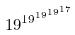Convert formula to latex. <formula><loc_0><loc_0><loc_500><loc_500>1 9 ^ { 1 9 ^ { 1 9 ^ { 1 9 ^ { 1 7 } } } }</formula> 